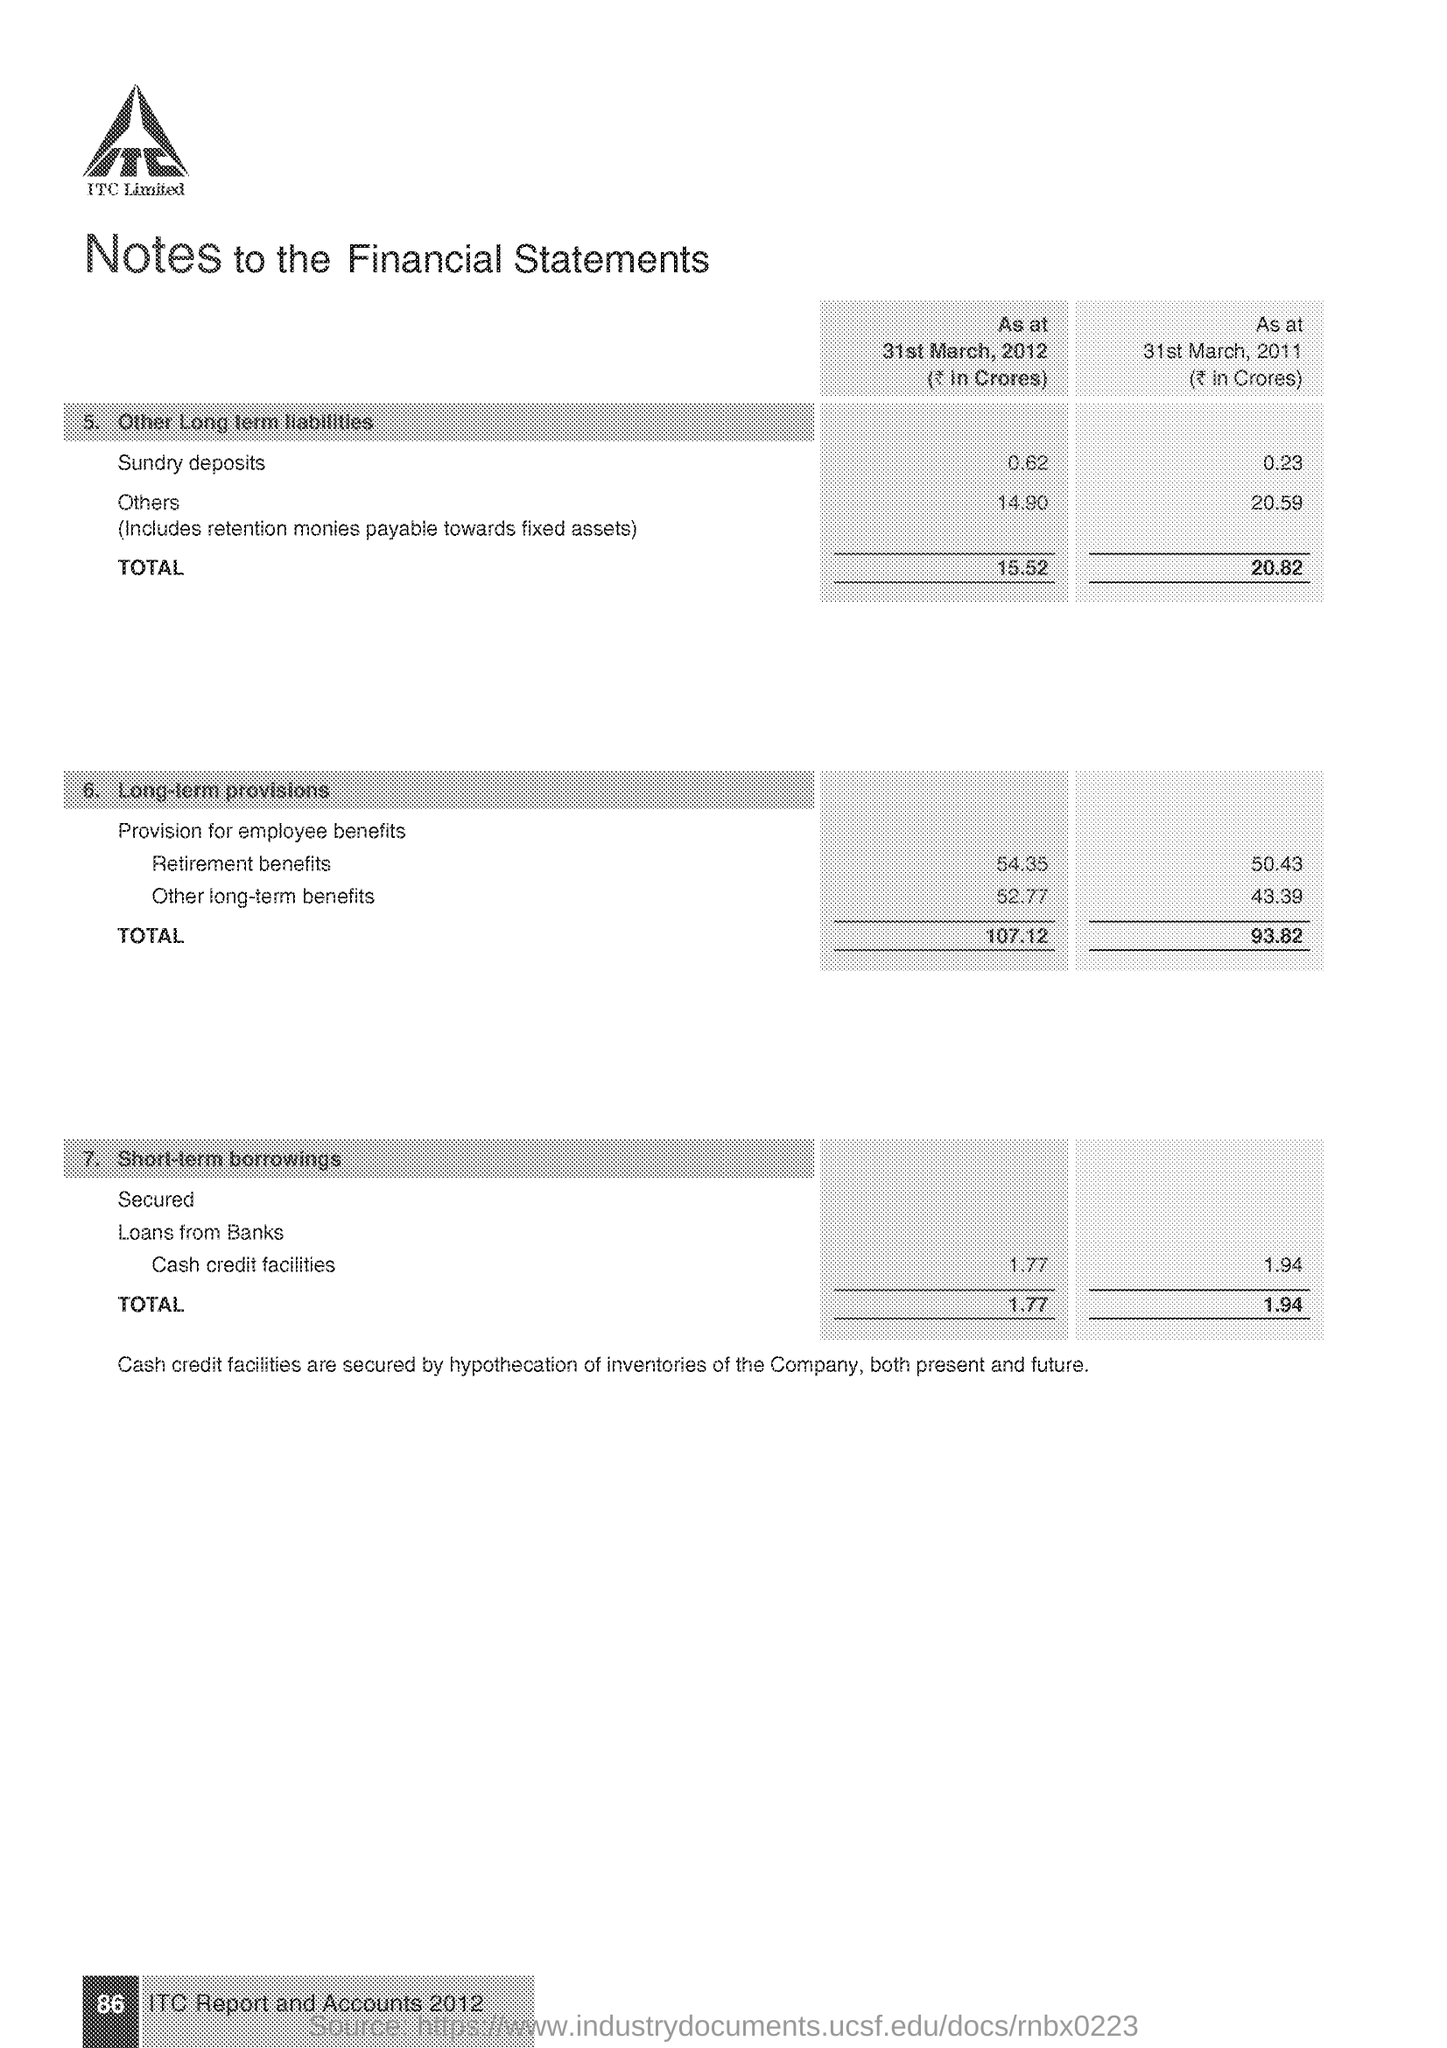What is the total Long term provisions as at 31st March 2012 (₹ in crores)?
Provide a short and direct response. 107.12. What is the total Long term provisions as at 31st March 2011 (₹ in crores)?
Provide a short and direct response. 93.82. What is the Total Short-term borrowings as at 31st March 2012 (₹ in crores)?
Provide a succinct answer. 1.77. What is the Total Short-term borrowings as at 31st March 2011 (₹ in crores)?
Your answer should be compact. 1.94. What is the total Other Long Term Liabilities as at 31st March 2012 (₹ in crores)?
Make the answer very short. 15.52. What is the total Other Long Term Liabilities as at 31st March 2011 (₹ in crores)?
Provide a short and direct response. 20.82. What is the page no mentioned in this document?
Your response must be concise. 86. Which Company's Notes to the Financial Statements is given here?
Offer a terse response. ITC Limited. 